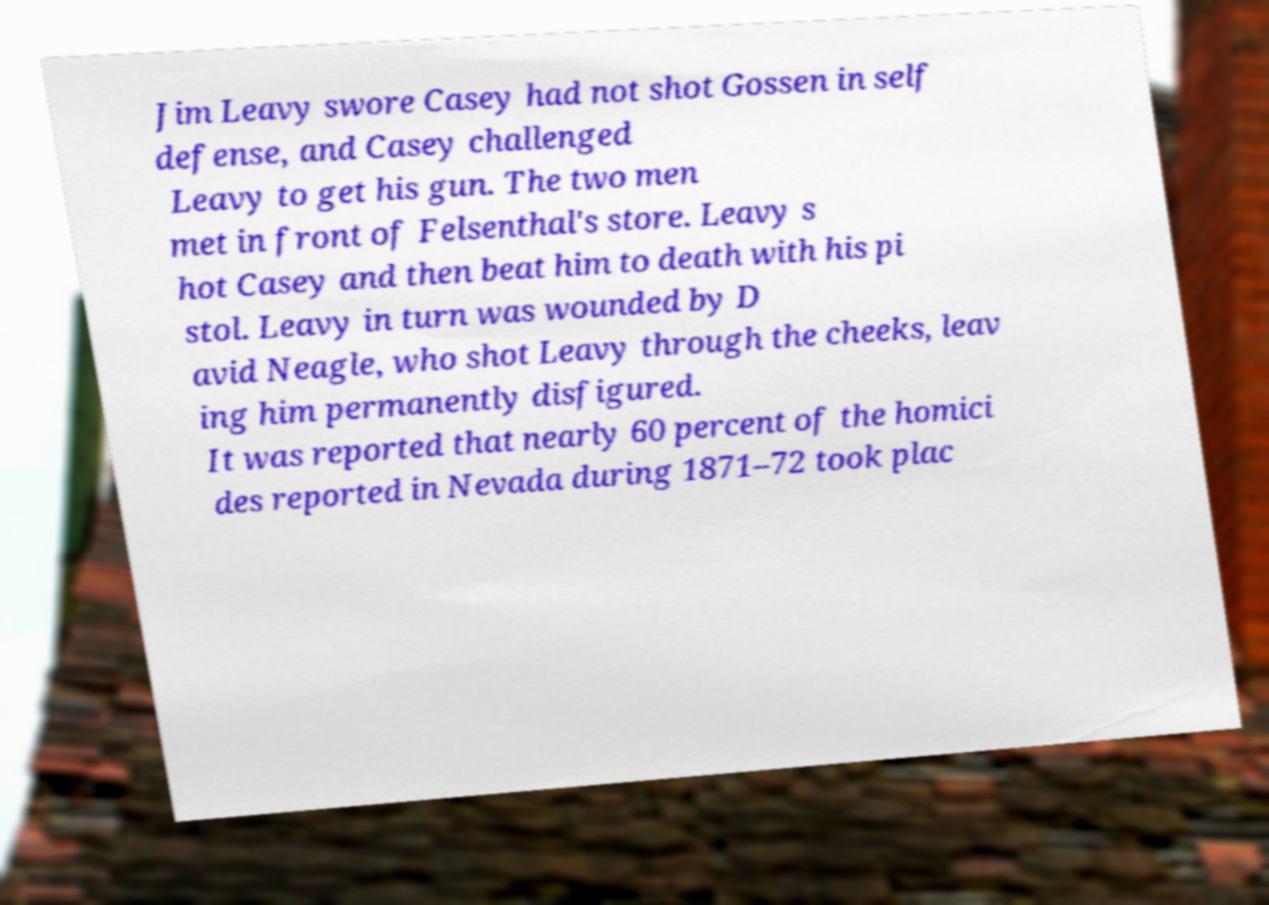Could you assist in decoding the text presented in this image and type it out clearly? Jim Leavy swore Casey had not shot Gossen in self defense, and Casey challenged Leavy to get his gun. The two men met in front of Felsenthal's store. Leavy s hot Casey and then beat him to death with his pi stol. Leavy in turn was wounded by D avid Neagle, who shot Leavy through the cheeks, leav ing him permanently disfigured. It was reported that nearly 60 percent of the homici des reported in Nevada during 1871–72 took plac 